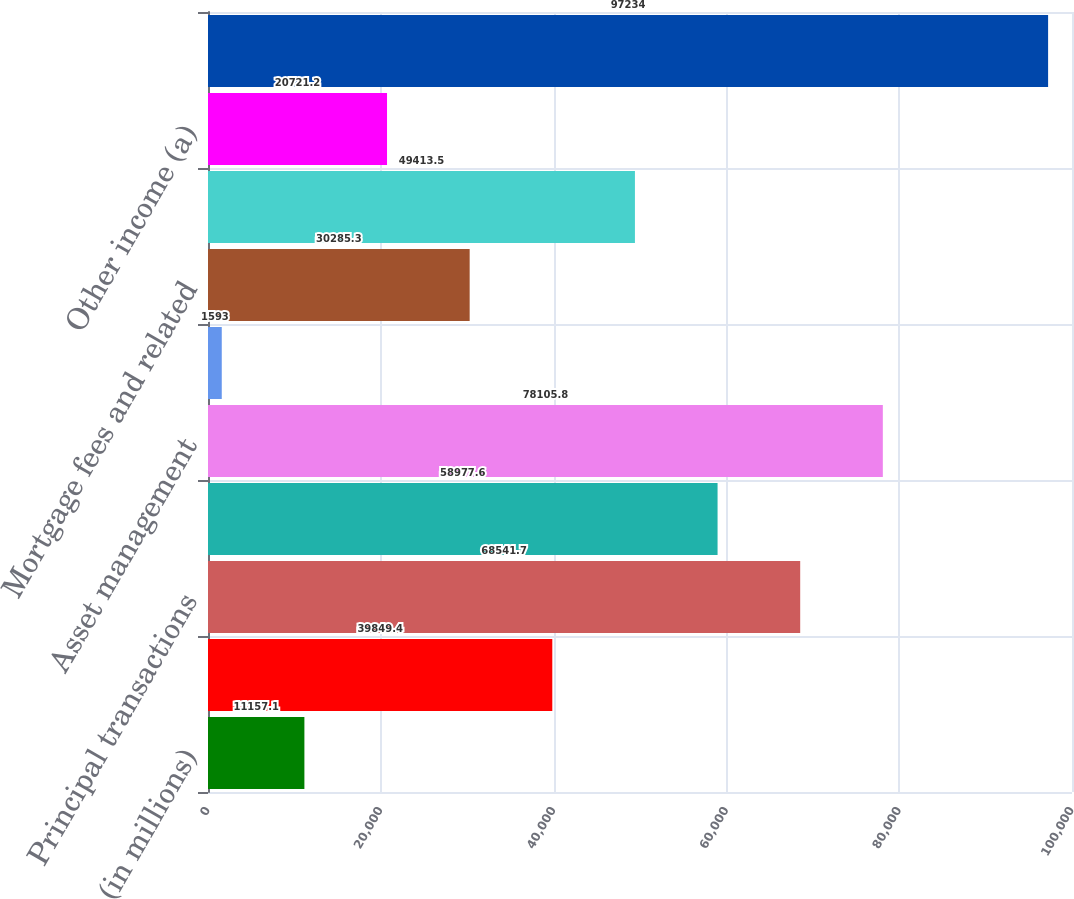Convert chart to OTSL. <chart><loc_0><loc_0><loc_500><loc_500><bar_chart><fcel>(in millions)<fcel>Investment banking fees<fcel>Principal transactions<fcel>Lending- and deposit-related<fcel>Asset management<fcel>Securities gains<fcel>Mortgage fees and related<fcel>Card income<fcel>Other income (a)<fcel>Noninterest revenue<nl><fcel>11157.1<fcel>39849.4<fcel>68541.7<fcel>58977.6<fcel>78105.8<fcel>1593<fcel>30285.3<fcel>49413.5<fcel>20721.2<fcel>97234<nl></chart> 